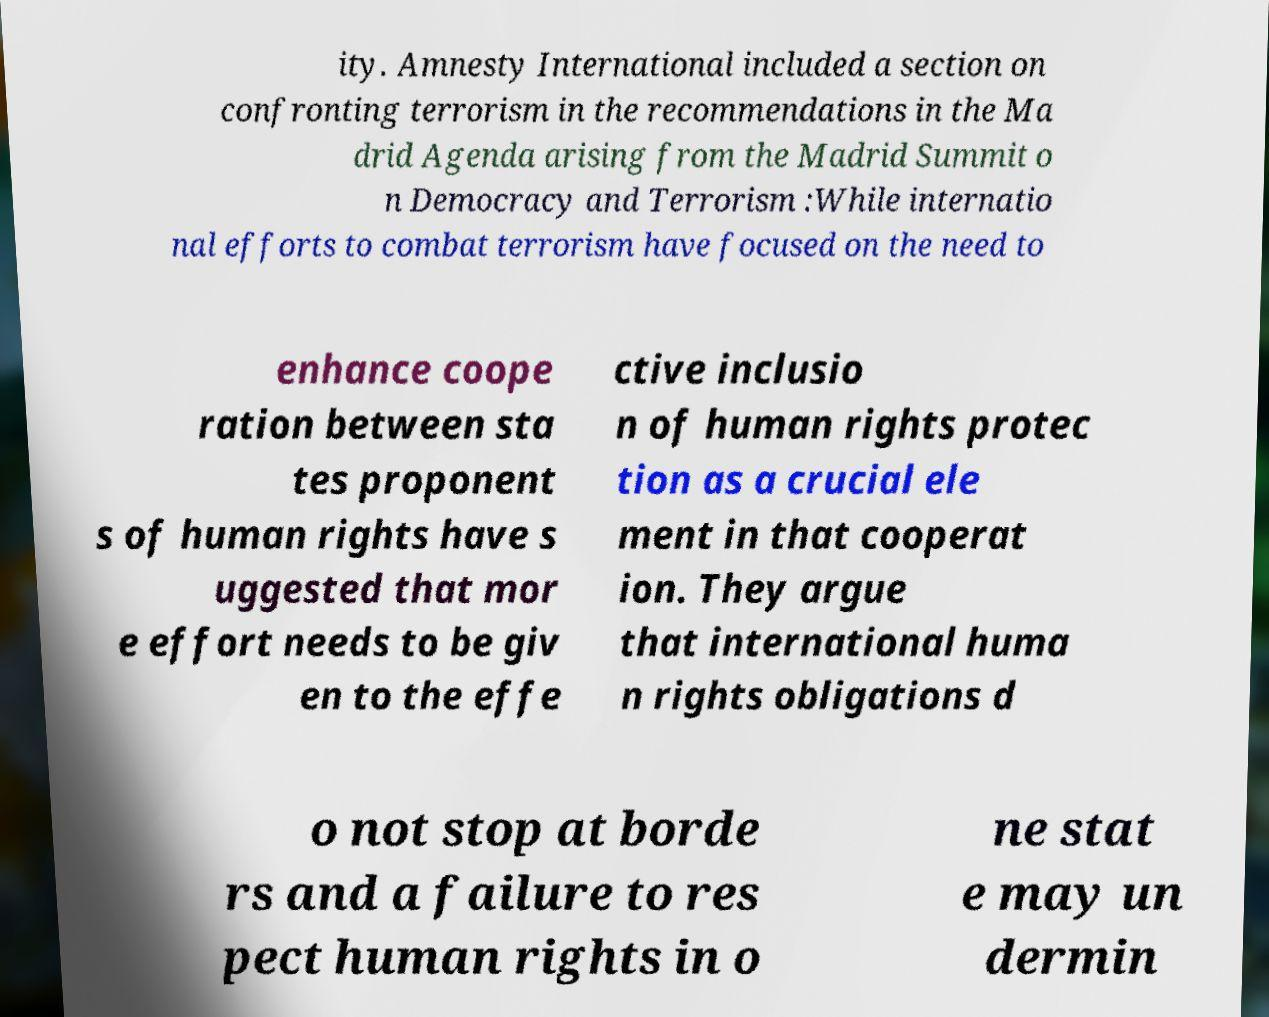There's text embedded in this image that I need extracted. Can you transcribe it verbatim? ity. Amnesty International included a section on confronting terrorism in the recommendations in the Ma drid Agenda arising from the Madrid Summit o n Democracy and Terrorism :While internatio nal efforts to combat terrorism have focused on the need to enhance coope ration between sta tes proponent s of human rights have s uggested that mor e effort needs to be giv en to the effe ctive inclusio n of human rights protec tion as a crucial ele ment in that cooperat ion. They argue that international huma n rights obligations d o not stop at borde rs and a failure to res pect human rights in o ne stat e may un dermin 